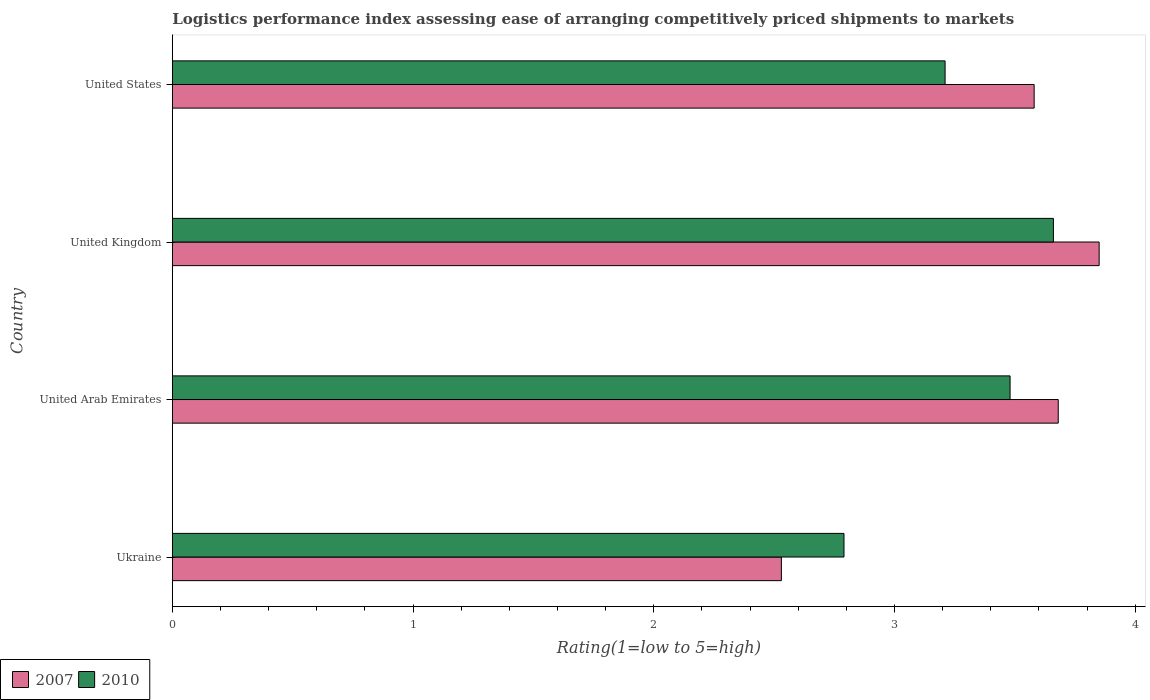How many different coloured bars are there?
Your answer should be very brief. 2. How many groups of bars are there?
Your response must be concise. 4. What is the Logistic performance index in 2007 in United Arab Emirates?
Offer a terse response. 3.68. Across all countries, what is the maximum Logistic performance index in 2010?
Offer a terse response. 3.66. Across all countries, what is the minimum Logistic performance index in 2007?
Your response must be concise. 2.53. In which country was the Logistic performance index in 2010 maximum?
Offer a very short reply. United Kingdom. In which country was the Logistic performance index in 2007 minimum?
Ensure brevity in your answer.  Ukraine. What is the total Logistic performance index in 2007 in the graph?
Your response must be concise. 13.64. What is the difference between the Logistic performance index in 2007 in Ukraine and that in United Kingdom?
Ensure brevity in your answer.  -1.32. What is the difference between the Logistic performance index in 2010 in United States and the Logistic performance index in 2007 in Ukraine?
Ensure brevity in your answer.  0.68. What is the average Logistic performance index in 2007 per country?
Your answer should be compact. 3.41. What is the difference between the Logistic performance index in 2007 and Logistic performance index in 2010 in United Arab Emirates?
Keep it short and to the point. 0.2. What is the ratio of the Logistic performance index in 2010 in Ukraine to that in United Arab Emirates?
Offer a terse response. 0.8. Is the Logistic performance index in 2007 in United Kingdom less than that in United States?
Ensure brevity in your answer.  No. Is the difference between the Logistic performance index in 2007 in United Arab Emirates and United States greater than the difference between the Logistic performance index in 2010 in United Arab Emirates and United States?
Your answer should be very brief. No. What is the difference between the highest and the second highest Logistic performance index in 2007?
Offer a very short reply. 0.17. What is the difference between the highest and the lowest Logistic performance index in 2010?
Keep it short and to the point. 0.87. What does the 1st bar from the bottom in Ukraine represents?
Give a very brief answer. 2007. Are all the bars in the graph horizontal?
Your answer should be very brief. Yes. What is the difference between two consecutive major ticks on the X-axis?
Offer a terse response. 1. How many legend labels are there?
Make the answer very short. 2. How are the legend labels stacked?
Your response must be concise. Horizontal. What is the title of the graph?
Offer a very short reply. Logistics performance index assessing ease of arranging competitively priced shipments to markets. What is the label or title of the X-axis?
Your answer should be compact. Rating(1=low to 5=high). What is the Rating(1=low to 5=high) of 2007 in Ukraine?
Offer a terse response. 2.53. What is the Rating(1=low to 5=high) of 2010 in Ukraine?
Offer a terse response. 2.79. What is the Rating(1=low to 5=high) of 2007 in United Arab Emirates?
Ensure brevity in your answer.  3.68. What is the Rating(1=low to 5=high) of 2010 in United Arab Emirates?
Make the answer very short. 3.48. What is the Rating(1=low to 5=high) in 2007 in United Kingdom?
Keep it short and to the point. 3.85. What is the Rating(1=low to 5=high) in 2010 in United Kingdom?
Give a very brief answer. 3.66. What is the Rating(1=low to 5=high) in 2007 in United States?
Give a very brief answer. 3.58. What is the Rating(1=low to 5=high) in 2010 in United States?
Ensure brevity in your answer.  3.21. Across all countries, what is the maximum Rating(1=low to 5=high) of 2007?
Offer a very short reply. 3.85. Across all countries, what is the maximum Rating(1=low to 5=high) in 2010?
Make the answer very short. 3.66. Across all countries, what is the minimum Rating(1=low to 5=high) in 2007?
Ensure brevity in your answer.  2.53. Across all countries, what is the minimum Rating(1=low to 5=high) in 2010?
Offer a terse response. 2.79. What is the total Rating(1=low to 5=high) of 2007 in the graph?
Give a very brief answer. 13.64. What is the total Rating(1=low to 5=high) of 2010 in the graph?
Offer a very short reply. 13.14. What is the difference between the Rating(1=low to 5=high) in 2007 in Ukraine and that in United Arab Emirates?
Offer a terse response. -1.15. What is the difference between the Rating(1=low to 5=high) of 2010 in Ukraine and that in United Arab Emirates?
Your answer should be very brief. -0.69. What is the difference between the Rating(1=low to 5=high) of 2007 in Ukraine and that in United Kingdom?
Make the answer very short. -1.32. What is the difference between the Rating(1=low to 5=high) of 2010 in Ukraine and that in United Kingdom?
Provide a short and direct response. -0.87. What is the difference between the Rating(1=low to 5=high) of 2007 in Ukraine and that in United States?
Your answer should be very brief. -1.05. What is the difference between the Rating(1=low to 5=high) in 2010 in Ukraine and that in United States?
Give a very brief answer. -0.42. What is the difference between the Rating(1=low to 5=high) of 2007 in United Arab Emirates and that in United Kingdom?
Provide a succinct answer. -0.17. What is the difference between the Rating(1=low to 5=high) in 2010 in United Arab Emirates and that in United Kingdom?
Make the answer very short. -0.18. What is the difference between the Rating(1=low to 5=high) of 2010 in United Arab Emirates and that in United States?
Offer a terse response. 0.27. What is the difference between the Rating(1=low to 5=high) in 2007 in United Kingdom and that in United States?
Provide a succinct answer. 0.27. What is the difference between the Rating(1=low to 5=high) in 2010 in United Kingdom and that in United States?
Provide a short and direct response. 0.45. What is the difference between the Rating(1=low to 5=high) of 2007 in Ukraine and the Rating(1=low to 5=high) of 2010 in United Arab Emirates?
Offer a terse response. -0.95. What is the difference between the Rating(1=low to 5=high) in 2007 in Ukraine and the Rating(1=low to 5=high) in 2010 in United Kingdom?
Ensure brevity in your answer.  -1.13. What is the difference between the Rating(1=low to 5=high) in 2007 in Ukraine and the Rating(1=low to 5=high) in 2010 in United States?
Offer a very short reply. -0.68. What is the difference between the Rating(1=low to 5=high) of 2007 in United Arab Emirates and the Rating(1=low to 5=high) of 2010 in United States?
Give a very brief answer. 0.47. What is the difference between the Rating(1=low to 5=high) of 2007 in United Kingdom and the Rating(1=low to 5=high) of 2010 in United States?
Your answer should be compact. 0.64. What is the average Rating(1=low to 5=high) of 2007 per country?
Your answer should be compact. 3.41. What is the average Rating(1=low to 5=high) in 2010 per country?
Your response must be concise. 3.29. What is the difference between the Rating(1=low to 5=high) in 2007 and Rating(1=low to 5=high) in 2010 in Ukraine?
Offer a very short reply. -0.26. What is the difference between the Rating(1=low to 5=high) of 2007 and Rating(1=low to 5=high) of 2010 in United Arab Emirates?
Your response must be concise. 0.2. What is the difference between the Rating(1=low to 5=high) of 2007 and Rating(1=low to 5=high) of 2010 in United Kingdom?
Offer a very short reply. 0.19. What is the difference between the Rating(1=low to 5=high) in 2007 and Rating(1=low to 5=high) in 2010 in United States?
Offer a terse response. 0.37. What is the ratio of the Rating(1=low to 5=high) of 2007 in Ukraine to that in United Arab Emirates?
Your response must be concise. 0.69. What is the ratio of the Rating(1=low to 5=high) in 2010 in Ukraine to that in United Arab Emirates?
Give a very brief answer. 0.8. What is the ratio of the Rating(1=low to 5=high) of 2007 in Ukraine to that in United Kingdom?
Ensure brevity in your answer.  0.66. What is the ratio of the Rating(1=low to 5=high) in 2010 in Ukraine to that in United Kingdom?
Your answer should be very brief. 0.76. What is the ratio of the Rating(1=low to 5=high) in 2007 in Ukraine to that in United States?
Keep it short and to the point. 0.71. What is the ratio of the Rating(1=low to 5=high) in 2010 in Ukraine to that in United States?
Give a very brief answer. 0.87. What is the ratio of the Rating(1=low to 5=high) of 2007 in United Arab Emirates to that in United Kingdom?
Offer a very short reply. 0.96. What is the ratio of the Rating(1=low to 5=high) in 2010 in United Arab Emirates to that in United Kingdom?
Your answer should be compact. 0.95. What is the ratio of the Rating(1=low to 5=high) of 2007 in United Arab Emirates to that in United States?
Keep it short and to the point. 1.03. What is the ratio of the Rating(1=low to 5=high) in 2010 in United Arab Emirates to that in United States?
Keep it short and to the point. 1.08. What is the ratio of the Rating(1=low to 5=high) of 2007 in United Kingdom to that in United States?
Offer a very short reply. 1.08. What is the ratio of the Rating(1=low to 5=high) of 2010 in United Kingdom to that in United States?
Offer a very short reply. 1.14. What is the difference between the highest and the second highest Rating(1=low to 5=high) in 2007?
Give a very brief answer. 0.17. What is the difference between the highest and the second highest Rating(1=low to 5=high) of 2010?
Your answer should be compact. 0.18. What is the difference between the highest and the lowest Rating(1=low to 5=high) of 2007?
Provide a succinct answer. 1.32. What is the difference between the highest and the lowest Rating(1=low to 5=high) of 2010?
Ensure brevity in your answer.  0.87. 